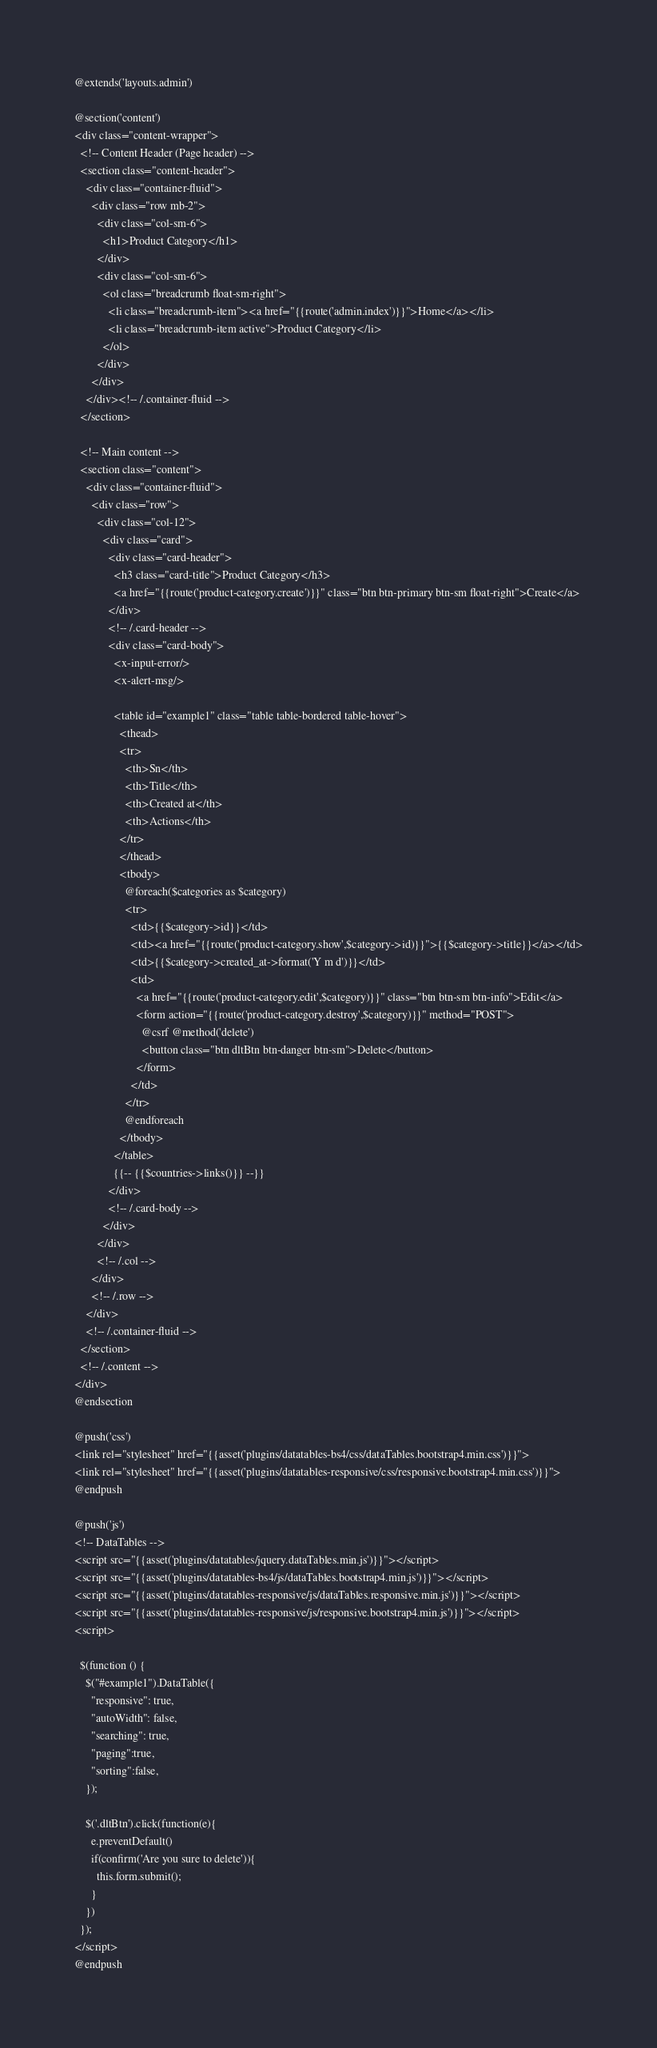Convert code to text. <code><loc_0><loc_0><loc_500><loc_500><_PHP_>@extends('layouts.admin')

@section('content')
<div class="content-wrapper">
  <!-- Content Header (Page header) -->
  <section class="content-header">
    <div class="container-fluid">
      <div class="row mb-2">
        <div class="col-sm-6">
          <h1>Product Category</h1>
        </div>
        <div class="col-sm-6">
          <ol class="breadcrumb float-sm-right">
            <li class="breadcrumb-item"><a href="{{route('admin.index')}}">Home</a></li>
            <li class="breadcrumb-item active">Product Category</li>
          </ol>
        </div>
      </div>
    </div><!-- /.container-fluid -->
  </section>

  <!-- Main content -->
  <section class="content">
    <div class="container-fluid">
      <div class="row">
        <div class="col-12">
          <div class="card">
            <div class="card-header">
              <h3 class="card-title">Product Category</h3>
              <a href="{{route('product-category.create')}}" class="btn btn-primary btn-sm float-right">Create</a>
            </div>
            <!-- /.card-header -->
            <div class="card-body">
              <x-input-error/>
              <x-alert-msg/>

              <table id="example1" class="table table-bordered table-hover">
                <thead>
                <tr>
                  <th>Sn</th>
                  <th>Title</th>
                  <th>Created at</th>
                  <th>Actions</th>
                </tr>
                </thead>
                <tbody>
                  @foreach($categories as $category)
                  <tr>
                    <td>{{$category->id}}</td>
                    <td><a href="{{route('product-category.show',$category->id)}}">{{$category->title}}</a></td>
                    <td>{{$category->created_at->format('Y m d')}}</td>
                    <td>
                      <a href="{{route('product-category.edit',$category)}}" class="btn btn-sm btn-info">Edit</a>
                      <form action="{{route('product-category.destroy',$category)}}" method="POST">
                        @csrf @method('delete')
                        <button class="btn dltBtn btn-danger btn-sm">Delete</button>
                      </form>
                    </td>
                  </tr>
                  @endforeach
                </tbody>
              </table>
              {{-- {{$countries->links()}} --}}
            </div>
            <!-- /.card-body -->
          </div>
        </div>
        <!-- /.col -->
      </div>
      <!-- /.row -->
    </div>
    <!-- /.container-fluid -->
  </section>
  <!-- /.content -->
</div>
@endsection

@push('css')
<link rel="stylesheet" href="{{asset('plugins/datatables-bs4/css/dataTables.bootstrap4.min.css')}}">
<link rel="stylesheet" href="{{asset('plugins/datatables-responsive/css/responsive.bootstrap4.min.css')}}">
@endpush

@push('js')
<!-- DataTables -->
<script src="{{asset('plugins/datatables/jquery.dataTables.min.js')}}"></script>
<script src="{{asset('plugins/datatables-bs4/js/dataTables.bootstrap4.min.js')}}"></script>
<script src="{{asset('plugins/datatables-responsive/js/dataTables.responsive.min.js')}}"></script>
<script src="{{asset('plugins/datatables-responsive/js/responsive.bootstrap4.min.js')}}"></script>
<script>
  
  $(function () {
    $("#example1").DataTable({
      "responsive": true,
      "autoWidth": false,
      "searching": true,
      "paging":true,
      "sorting":false,
    });

    $('.dltBtn').click(function(e){
      e.preventDefault()
      if(confirm('Are you sure to delete')){
        this.form.submit();
      }
    })
  });
</script>
@endpush</code> 